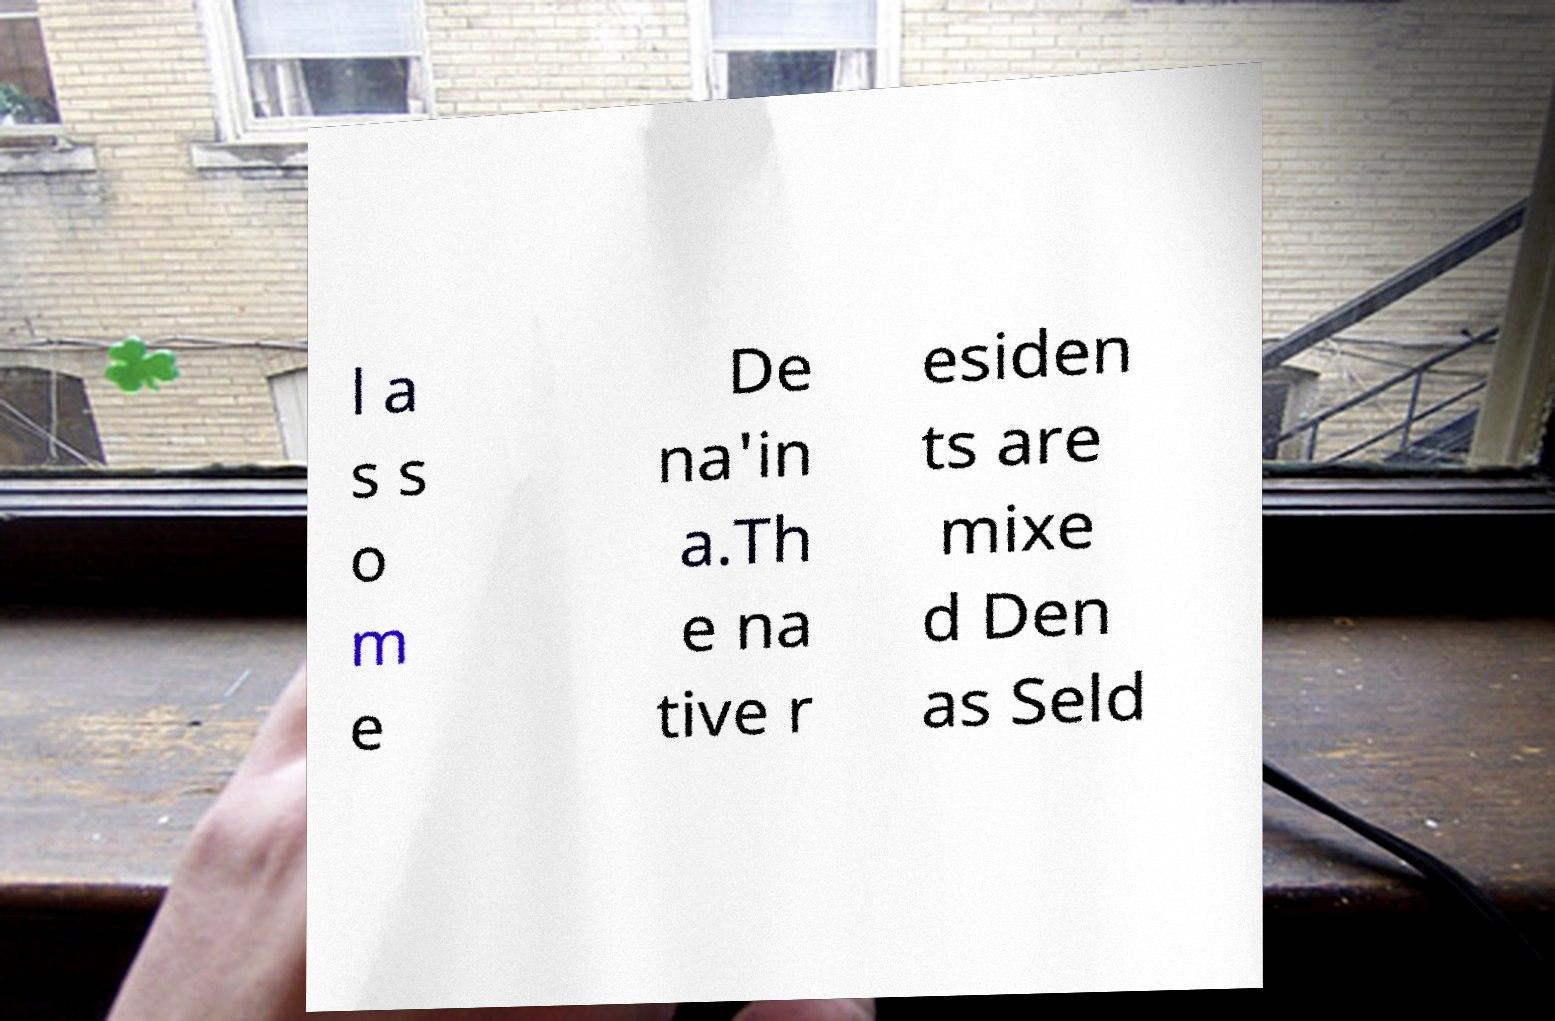Could you extract and type out the text from this image? l a s s o m e De na'in a.Th e na tive r esiden ts are mixe d Den as Seld 